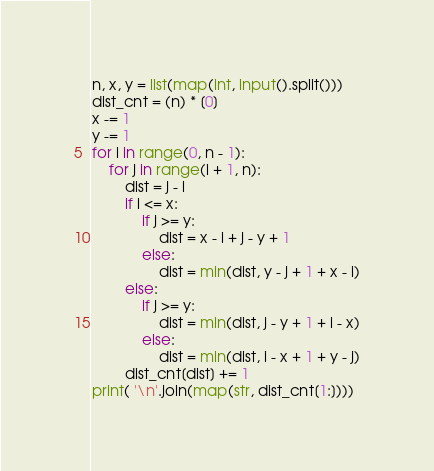Convert code to text. <code><loc_0><loc_0><loc_500><loc_500><_Python_>n, x, y = list(map(int, input().split()))
dist_cnt = (n) * [0]
x -= 1
y -= 1
for i in range(0, n - 1):
    for j in range(i + 1, n):
        dist = j - i
        if i <= x:
            if j >= y:
                dist = x - i + j - y + 1
            else:
                dist = min(dist, y - j + 1 + x - i)
        else:
            if j >= y:
                dist = min(dist, j - y + 1 + i - x)
            else:
                dist = min(dist, i - x + 1 + y - j)
        dist_cnt[dist] += 1
print( '\n'.join(map(str, dist_cnt[1:])))
</code> 